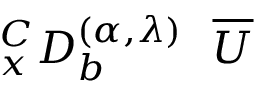Convert formula to latex. <formula><loc_0><loc_0><loc_500><loc_500>_ { x } ^ { C } D _ { b } ^ { ( \alpha , { \lambda } ) } \overline { U }</formula> 